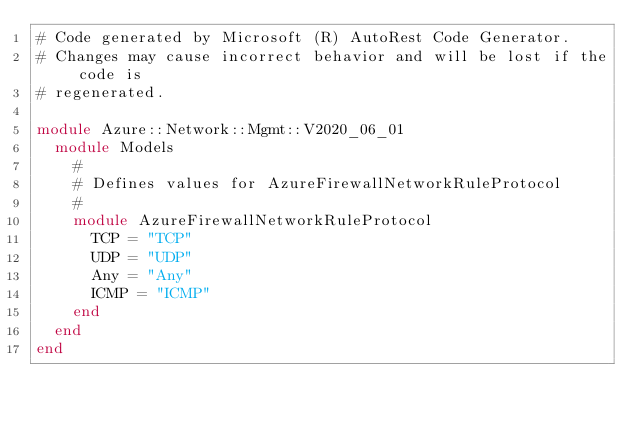<code> <loc_0><loc_0><loc_500><loc_500><_Ruby_># Code generated by Microsoft (R) AutoRest Code Generator.
# Changes may cause incorrect behavior and will be lost if the code is
# regenerated.

module Azure::Network::Mgmt::V2020_06_01
  module Models
    #
    # Defines values for AzureFirewallNetworkRuleProtocol
    #
    module AzureFirewallNetworkRuleProtocol
      TCP = "TCP"
      UDP = "UDP"
      Any = "Any"
      ICMP = "ICMP"
    end
  end
end
</code> 